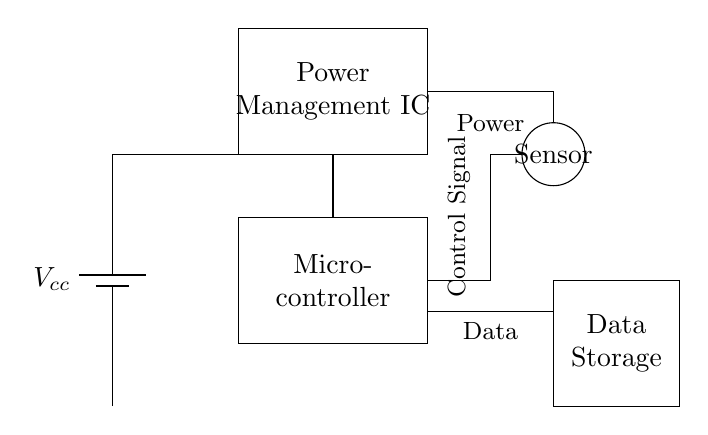What is the primary control element in this circuit? The primary control element is the microcontroller, which manages sensor data and controls other components.
Answer: microcontroller What component stores data in this system? The data storage component is clearly labeled in the circuit diagram and is responsible for holding the collected data.
Answer: Data Storage How many power management components are present? The circuit shows one power management integrated circuit which is responsible for regulating power in the system.
Answer: one What type of signal is indicated by the label near the connections? The label near the connections indicates a control signal, which the microcontroller sends to control components based on the sensor input.
Answer: Control Signal What is the role of the sensor in this circuit? The sensor's role is to detect environmental changes and send data to the microcontroller for processing.
Answer: Detect environmental changes Explain how power is supplied to the microcontroller. Power is supplied through the battery, which connects directly to the power management component first before reaching the microcontroller.
Answer: Battery to Power Management IC to Microcontroller What is the relationship between the sensor and data storage in this circuit? The relationship is that the sensor sends output data to the microcontroller, which processes it and then stores it in the data storage component.
Answer: Sensor outputs data to Microcontroller for storage 